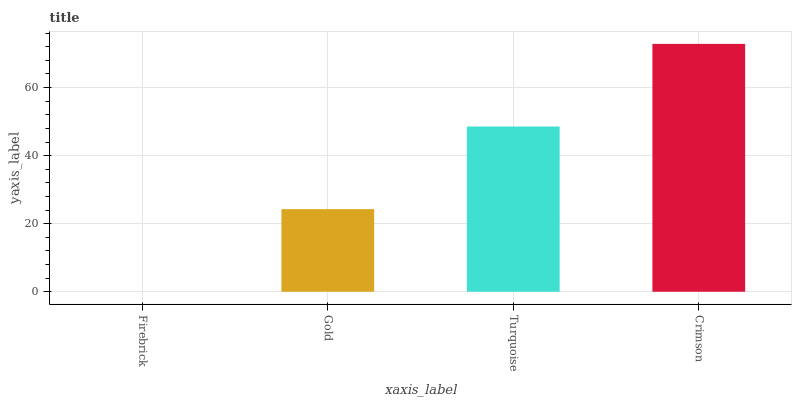Is Firebrick the minimum?
Answer yes or no. Yes. Is Crimson the maximum?
Answer yes or no. Yes. Is Gold the minimum?
Answer yes or no. No. Is Gold the maximum?
Answer yes or no. No. Is Gold greater than Firebrick?
Answer yes or no. Yes. Is Firebrick less than Gold?
Answer yes or no. Yes. Is Firebrick greater than Gold?
Answer yes or no. No. Is Gold less than Firebrick?
Answer yes or no. No. Is Turquoise the high median?
Answer yes or no. Yes. Is Gold the low median?
Answer yes or no. Yes. Is Crimson the high median?
Answer yes or no. No. Is Crimson the low median?
Answer yes or no. No. 